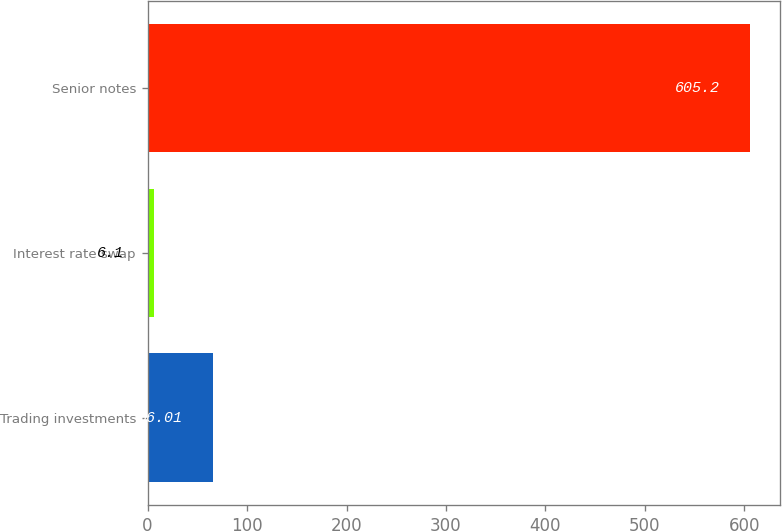Convert chart. <chart><loc_0><loc_0><loc_500><loc_500><bar_chart><fcel>Trading investments<fcel>Interest rate swap<fcel>Senior notes<nl><fcel>66.01<fcel>6.1<fcel>605.2<nl></chart> 